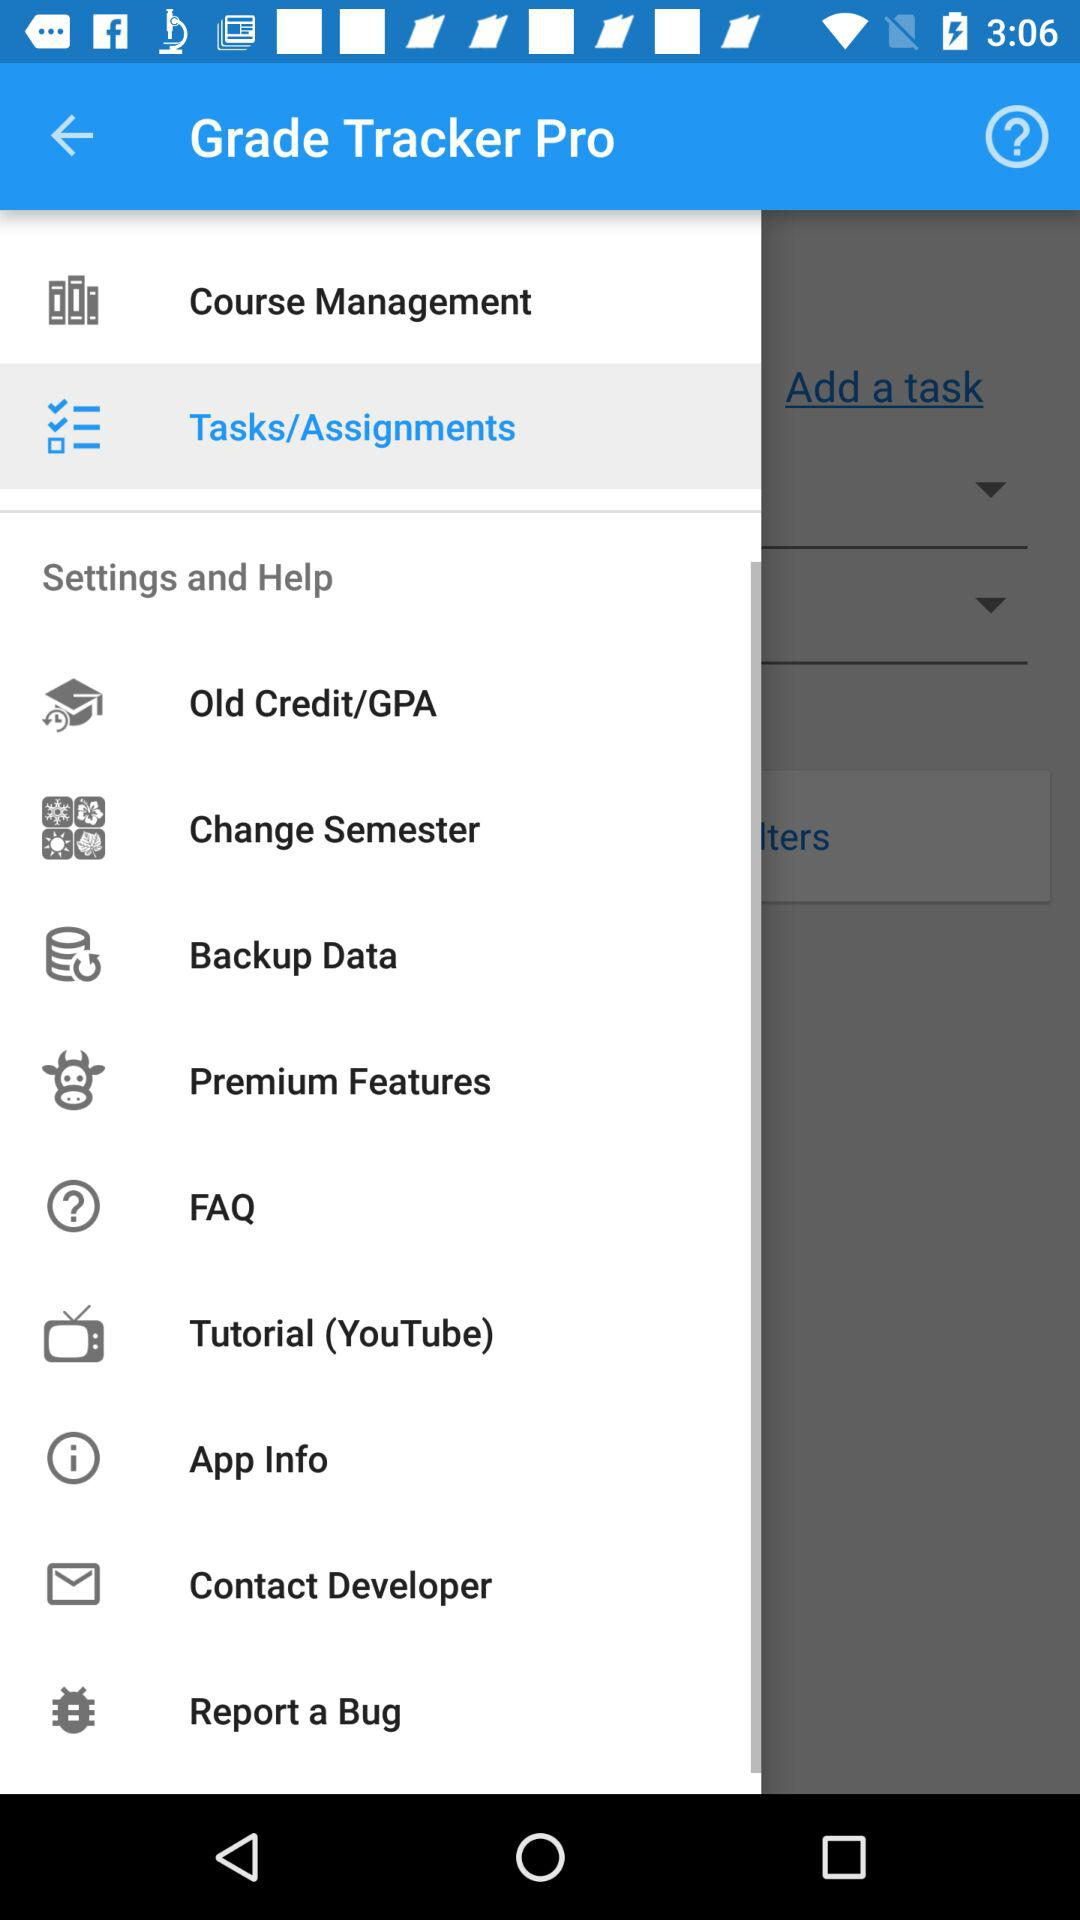What is the name of the application? The name of the application is "Grade Tracker Pro". 